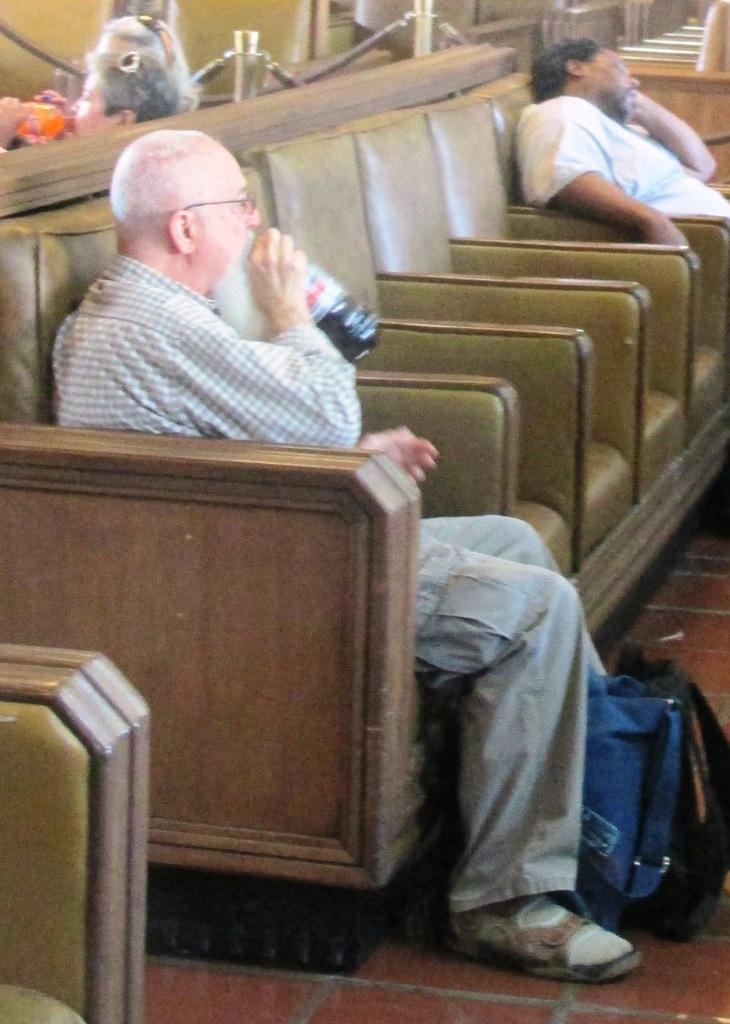What are the people in the image doing? The people in the image are sitting. How can you describe the clothing of the people in the image? The people are wearing different color dresses. What object is being held by one of the people in the image? One person is holding a bottle. What is located in front of the person holding the bottle? There is a bag in front of the person holding the bottle. How many pails can be seen in the image? There are no pails present in the image. What type of chairs are the people sitting on in the image? The provided facts do not mention the type of chairs the people are sitting on. 